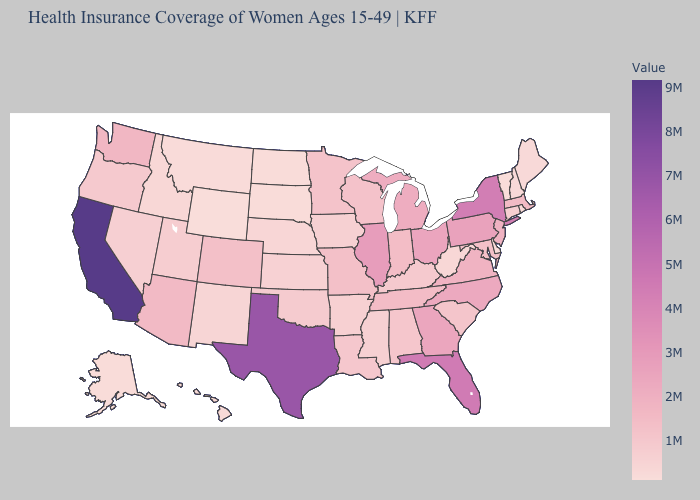Does California have the highest value in the USA?
Give a very brief answer. Yes. Does the map have missing data?
Write a very short answer. No. Does Rhode Island have a higher value than Arizona?
Write a very short answer. No. Does the map have missing data?
Short answer required. No. 